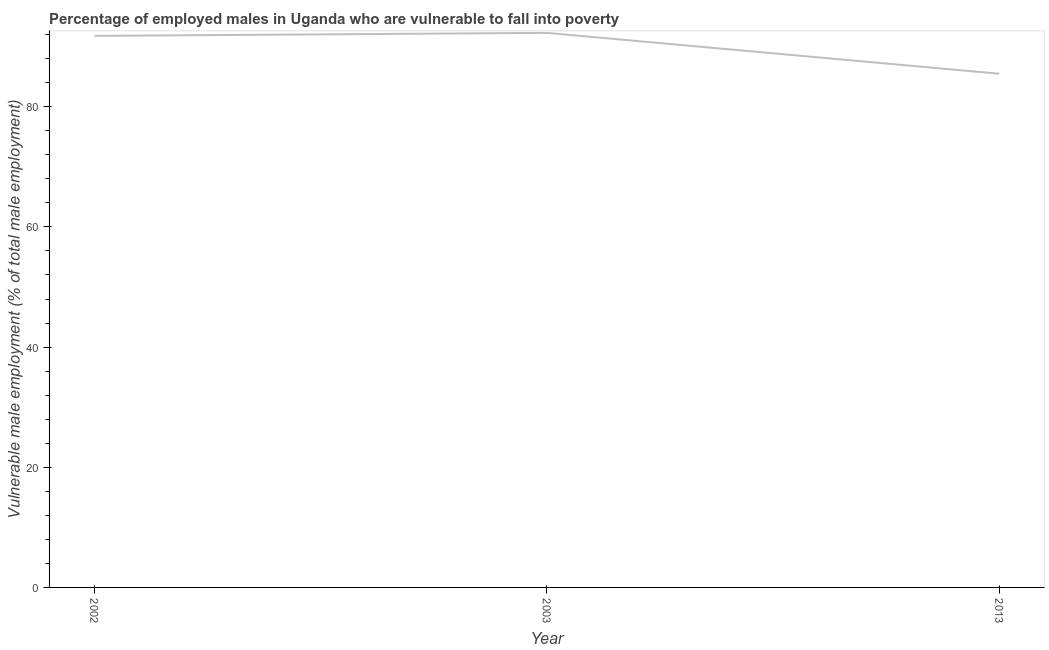What is the percentage of employed males who are vulnerable to fall into poverty in 2013?
Your answer should be compact. 85.5. Across all years, what is the maximum percentage of employed males who are vulnerable to fall into poverty?
Provide a short and direct response. 92.3. Across all years, what is the minimum percentage of employed males who are vulnerable to fall into poverty?
Offer a terse response. 85.5. In which year was the percentage of employed males who are vulnerable to fall into poverty minimum?
Provide a short and direct response. 2013. What is the sum of the percentage of employed males who are vulnerable to fall into poverty?
Make the answer very short. 269.6. What is the difference between the percentage of employed males who are vulnerable to fall into poverty in 2002 and 2013?
Offer a very short reply. 6.3. What is the average percentage of employed males who are vulnerable to fall into poverty per year?
Make the answer very short. 89.87. What is the median percentage of employed males who are vulnerable to fall into poverty?
Your response must be concise. 91.8. What is the ratio of the percentage of employed males who are vulnerable to fall into poverty in 2002 to that in 2013?
Your response must be concise. 1.07. Is the difference between the percentage of employed males who are vulnerable to fall into poverty in 2002 and 2003 greater than the difference between any two years?
Offer a very short reply. No. What is the difference between the highest and the lowest percentage of employed males who are vulnerable to fall into poverty?
Provide a succinct answer. 6.8. How many lines are there?
Offer a terse response. 1. How many years are there in the graph?
Ensure brevity in your answer.  3. What is the difference between two consecutive major ticks on the Y-axis?
Provide a short and direct response. 20. Are the values on the major ticks of Y-axis written in scientific E-notation?
Offer a terse response. No. Does the graph contain any zero values?
Your response must be concise. No. What is the title of the graph?
Keep it short and to the point. Percentage of employed males in Uganda who are vulnerable to fall into poverty. What is the label or title of the Y-axis?
Provide a succinct answer. Vulnerable male employment (% of total male employment). What is the Vulnerable male employment (% of total male employment) of 2002?
Offer a terse response. 91.8. What is the Vulnerable male employment (% of total male employment) in 2003?
Keep it short and to the point. 92.3. What is the Vulnerable male employment (% of total male employment) in 2013?
Your answer should be compact. 85.5. What is the difference between the Vulnerable male employment (% of total male employment) in 2002 and 2003?
Offer a terse response. -0.5. What is the difference between the Vulnerable male employment (% of total male employment) in 2002 and 2013?
Keep it short and to the point. 6.3. What is the ratio of the Vulnerable male employment (% of total male employment) in 2002 to that in 2003?
Offer a terse response. 0.99. What is the ratio of the Vulnerable male employment (% of total male employment) in 2002 to that in 2013?
Give a very brief answer. 1.07. What is the ratio of the Vulnerable male employment (% of total male employment) in 2003 to that in 2013?
Offer a very short reply. 1.08. 